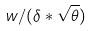<formula> <loc_0><loc_0><loc_500><loc_500>w / ( \delta * \sqrt { \theta } )</formula> 